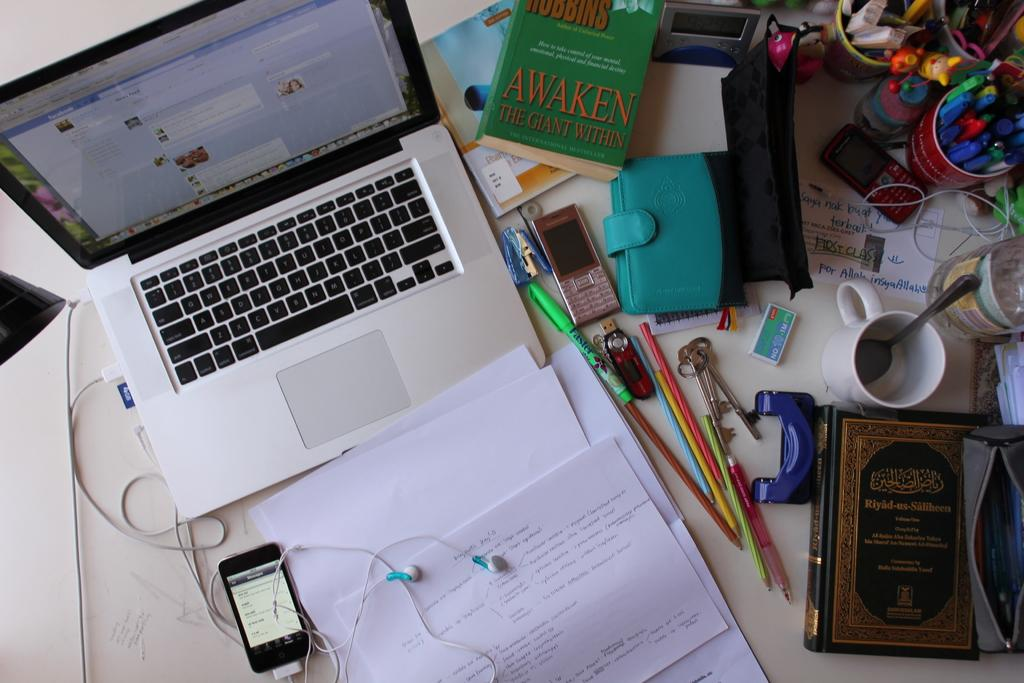What electronic device is visible in the image with earphones attached? There is a mobile with earphones in the image. What type of computer is present in the image? There is a laptop in the image. What type of stationery items can be seen in the image? There are papers and pen stands in the image. What type of beverage container is present in the image? There is a teacup in the image. What type of reading material is present in the image? There is a book in the image. How many wallets are visible in the image? There are two wallets in the image. What other electronic device is present on the table in the image? There is another mobile on the table in the image. Can you see any mittens on the sidewalk in the image? There is no sidewalk or mittens present in the image. What is the wish of the person using the laptop in the image? There is no information about the person's wish in the image. 